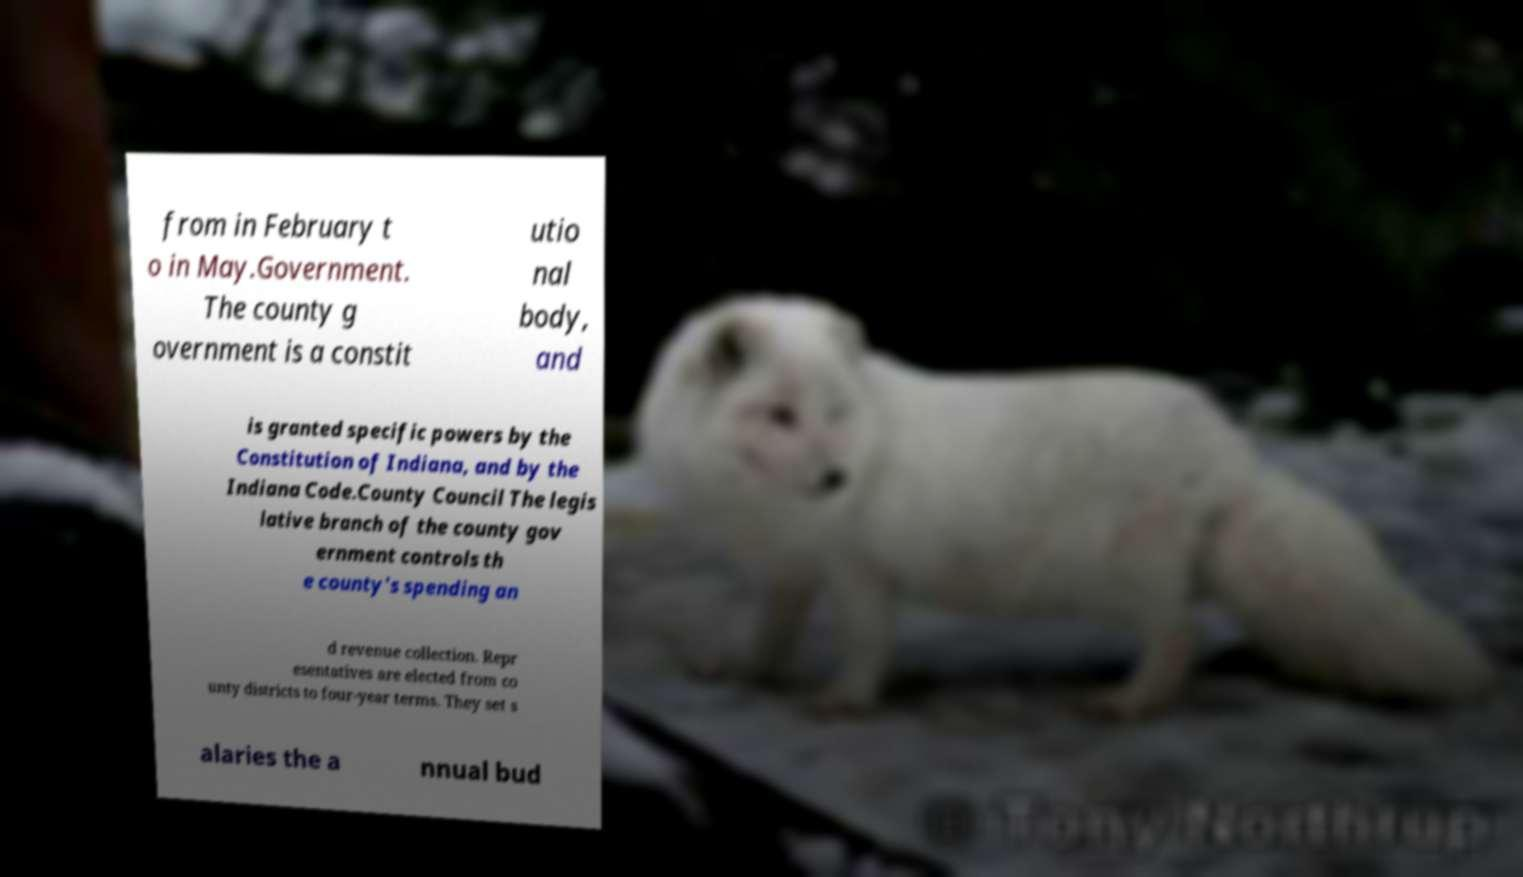Please identify and transcribe the text found in this image. from in February t o in May.Government. The county g overnment is a constit utio nal body, and is granted specific powers by the Constitution of Indiana, and by the Indiana Code.County Council The legis lative branch of the county gov ernment controls th e county's spending an d revenue collection. Repr esentatives are elected from co unty districts to four-year terms. They set s alaries the a nnual bud 